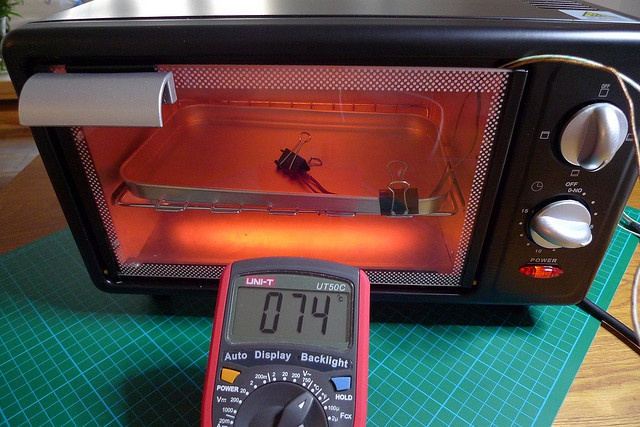Describe the objects in this image and their specific colors. I can see microwave in black, brown, maroon, and gray tones, oven in black, brown, maroon, and gray tones, and remote in black, gray, and salmon tones in this image. 